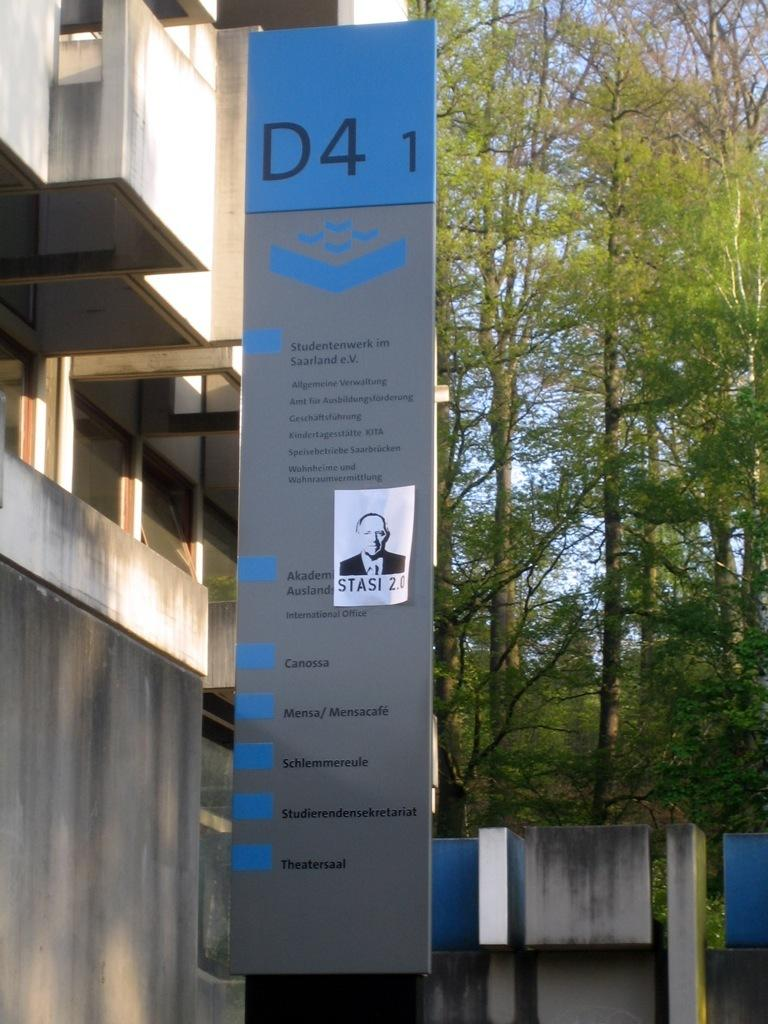What is located in the foreground of the image? There is a board in the foreground of the image. What structure can be seen on the left side of the image? There is a building on the left side of the image. What type of natural elements are visible in the background of the image? There are trees and the sky visible in the background of the image. What architectural feature can be seen in the background of the image? There is a wall in the background of the image. What type of transport is available for the horses in the image? There are no horses or transport present in the image. What stage of development is the building in the image? The provided facts do not give information about the development stage of the building. 